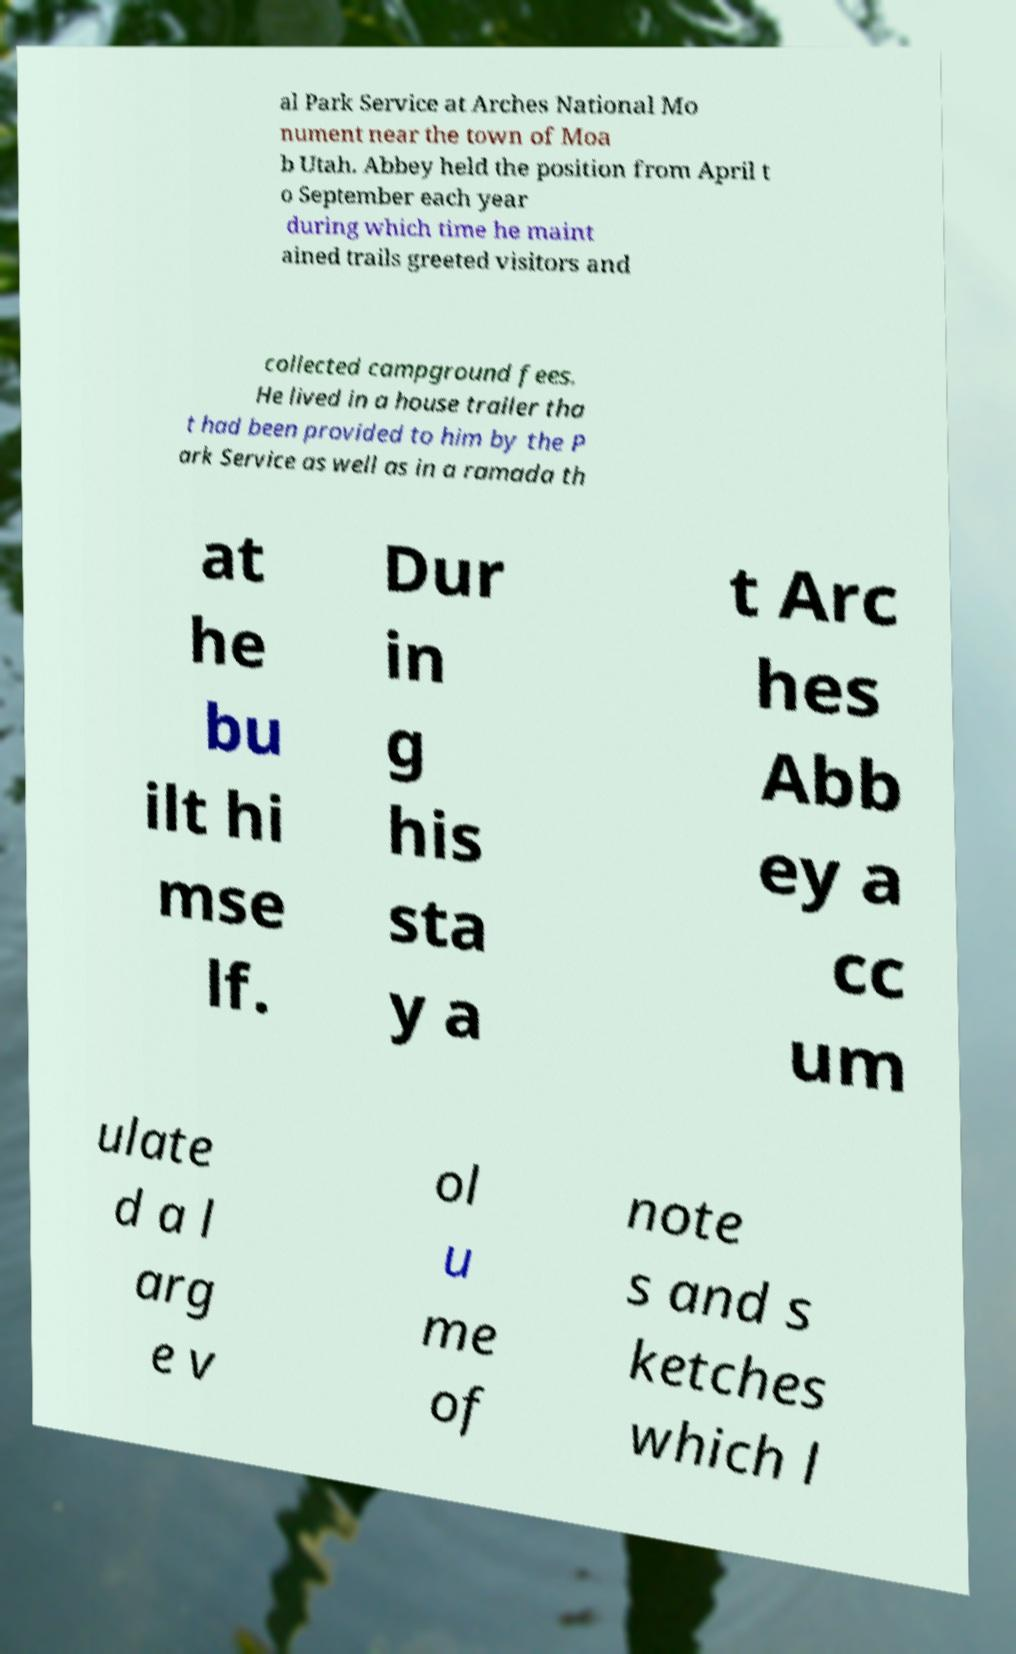There's text embedded in this image that I need extracted. Can you transcribe it verbatim? al Park Service at Arches National Mo nument near the town of Moa b Utah. Abbey held the position from April t o September each year during which time he maint ained trails greeted visitors and collected campground fees. He lived in a house trailer tha t had been provided to him by the P ark Service as well as in a ramada th at he bu ilt hi mse lf. Dur in g his sta y a t Arc hes Abb ey a cc um ulate d a l arg e v ol u me of note s and s ketches which l 